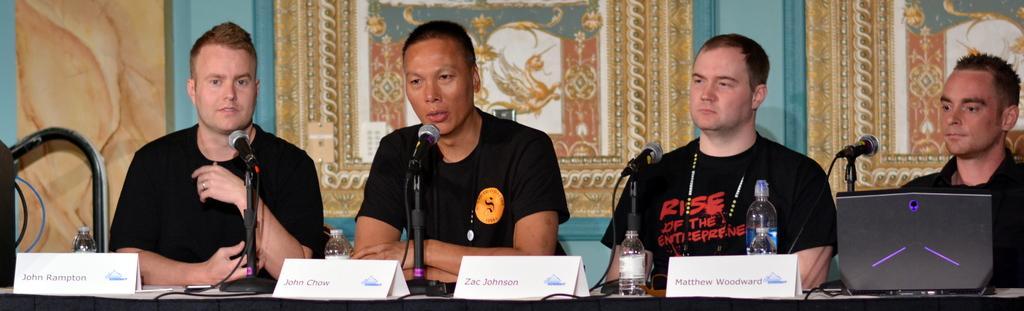In one or two sentences, can you explain what this image depicts? In this image I see 4 men who are sitting and I see that all of them are wearing black color t-shirts and I see the table on which there are name boards on which there is something written and I see the bottles and I can also see the mics, wires and a laptop over here. In the background I see the wall and I see 2 frames over here. 